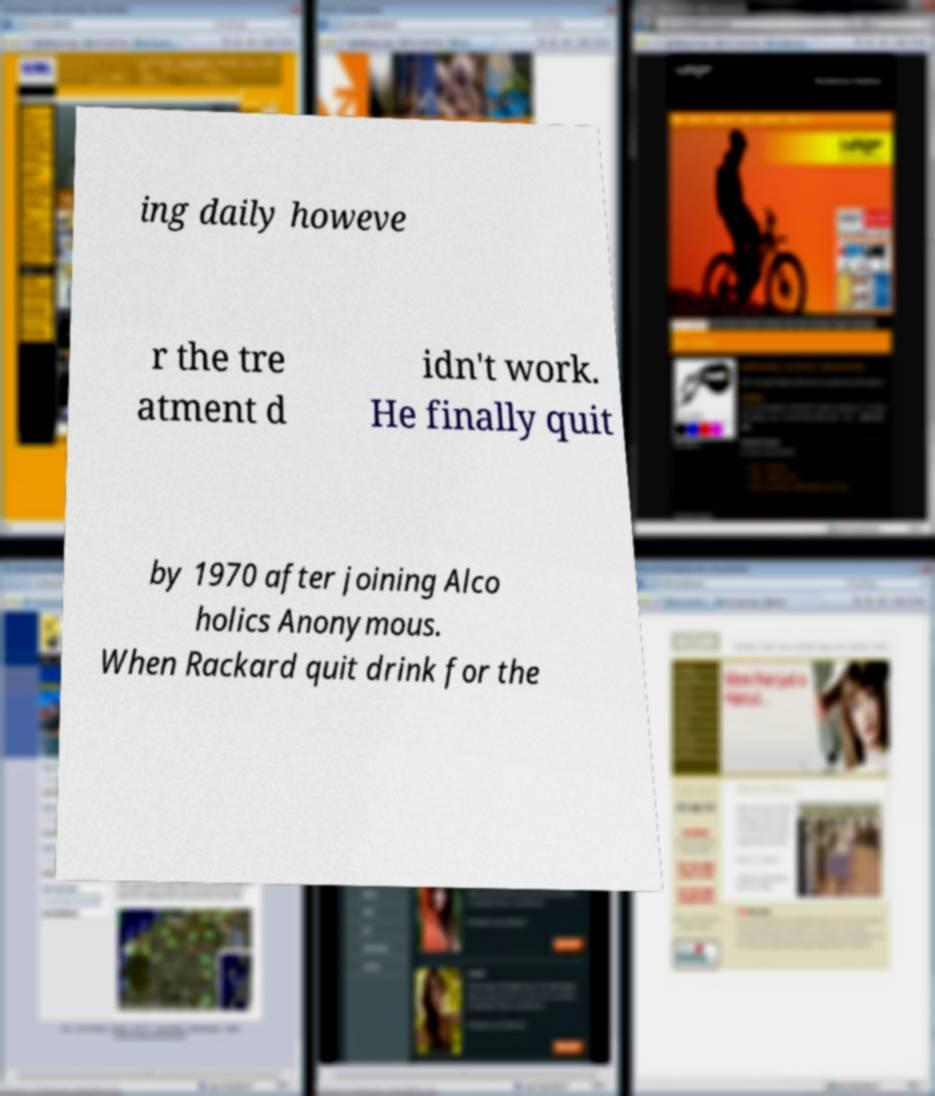Could you extract and type out the text from this image? ing daily howeve r the tre atment d idn't work. He finally quit by 1970 after joining Alco holics Anonymous. When Rackard quit drink for the 